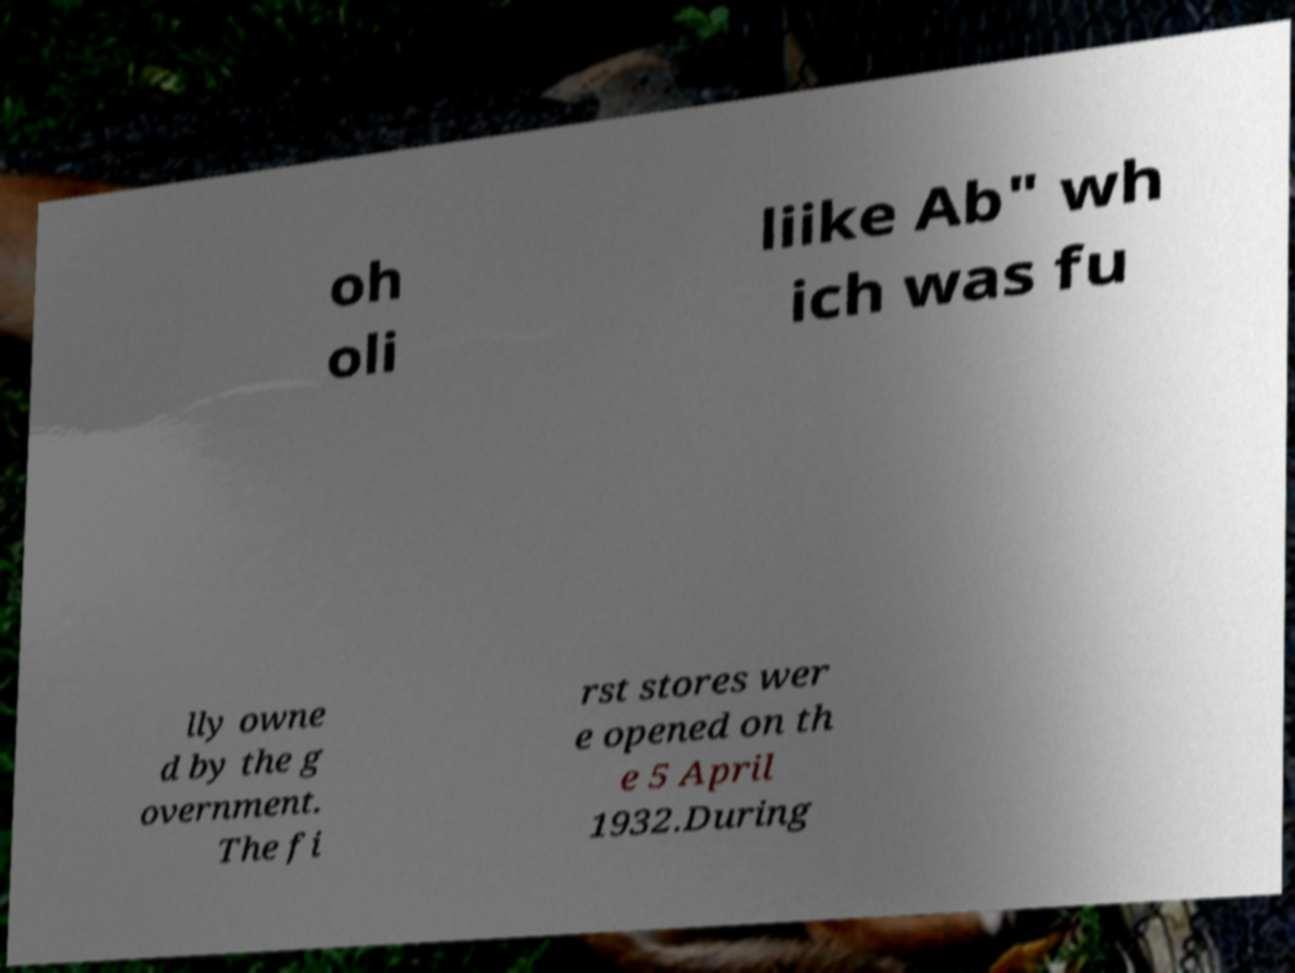Can you read and provide the text displayed in the image?This photo seems to have some interesting text. Can you extract and type it out for me? oh oli liike Ab" wh ich was fu lly owne d by the g overnment. The fi rst stores wer e opened on th e 5 April 1932.During 